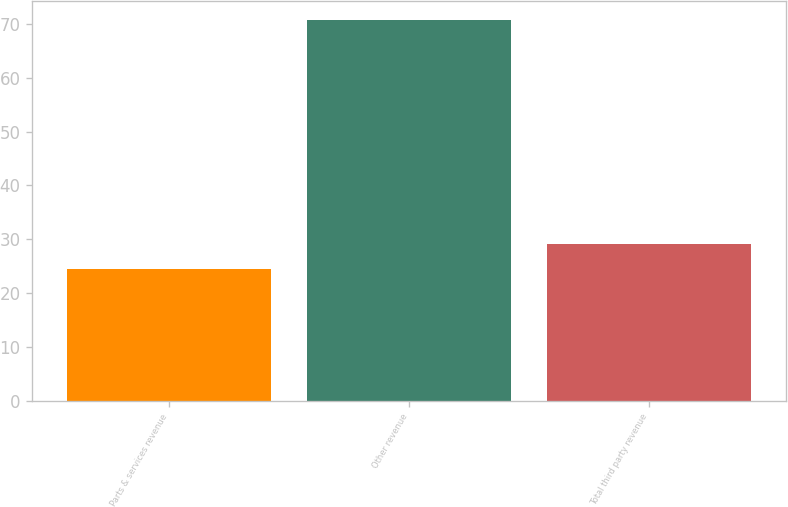<chart> <loc_0><loc_0><loc_500><loc_500><bar_chart><fcel>Parts & services revenue<fcel>Other revenue<fcel>Total third party revenue<nl><fcel>24.5<fcel>70.8<fcel>29.13<nl></chart> 